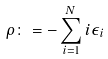<formula> <loc_0><loc_0><loc_500><loc_500>\rho \colon = - \sum _ { i = 1 } ^ { N } i \epsilon _ { i }</formula> 